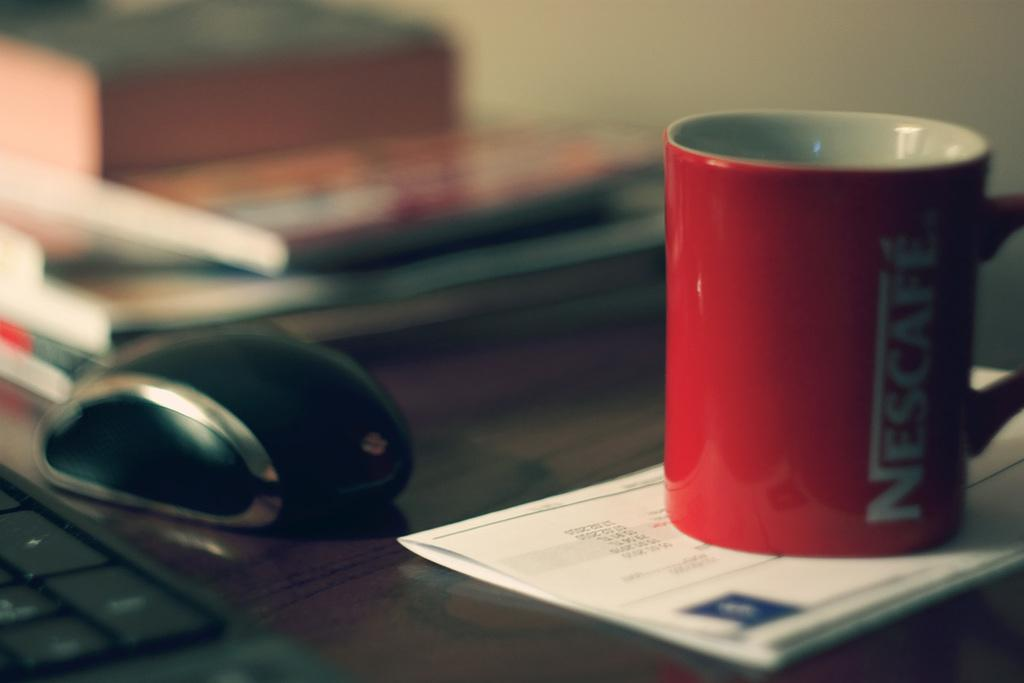<image>
Provide a brief description of the given image. a nescafe coffee cup is sitting on an envelope 